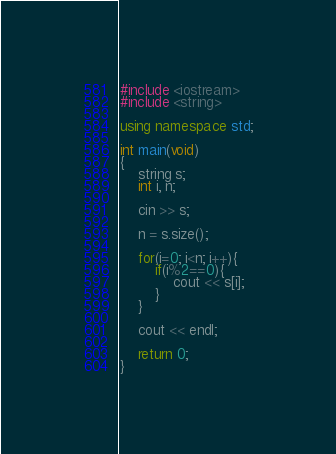<code> <loc_0><loc_0><loc_500><loc_500><_C++_>#include <iostream>
#include <string>

using namespace std;

int main(void)
{
    string s;
    int i, n;

    cin >> s;

    n = s.size();

    for(i=0; i<n; i++){
        if(i%2==0){
            cout << s[i];
        }
    }

    cout << endl;

    return 0;
}</code> 